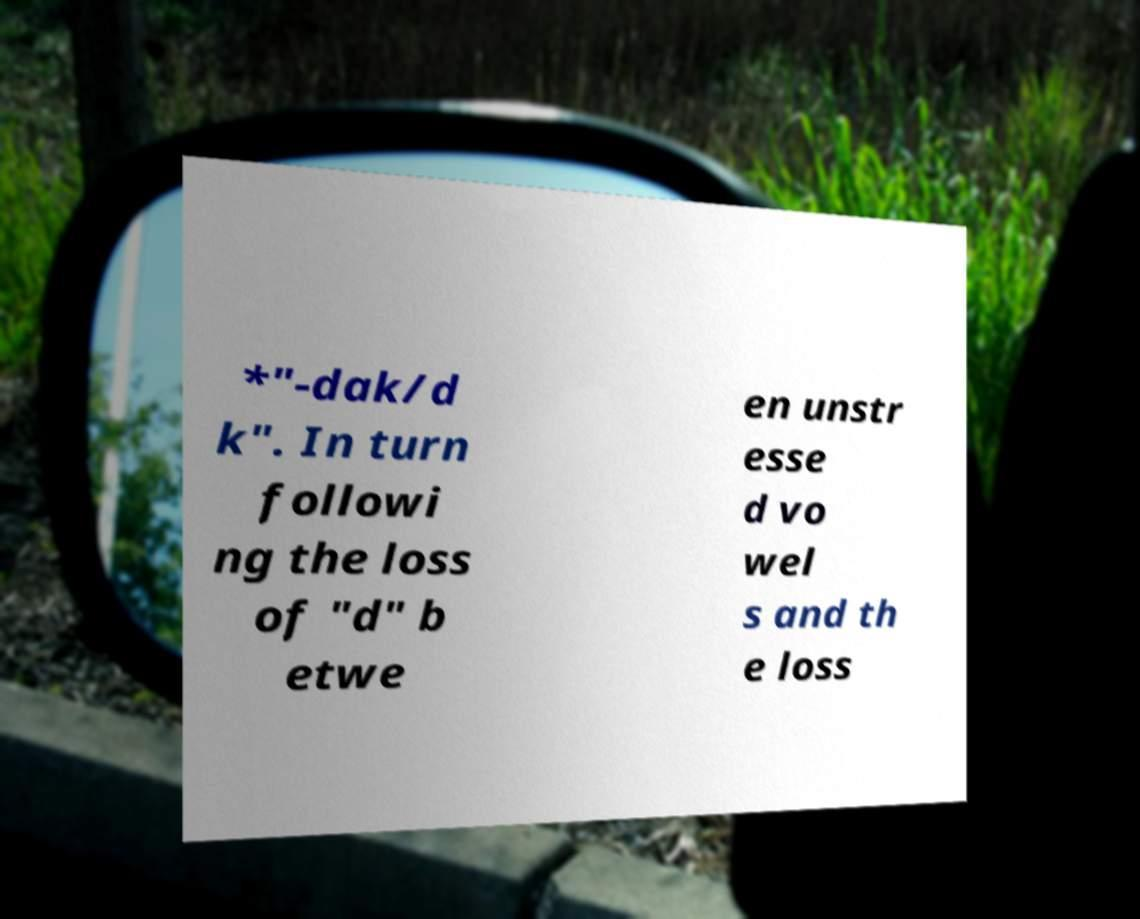Could you extract and type out the text from this image? *"-dak/d k". In turn followi ng the loss of "d" b etwe en unstr esse d vo wel s and th e loss 